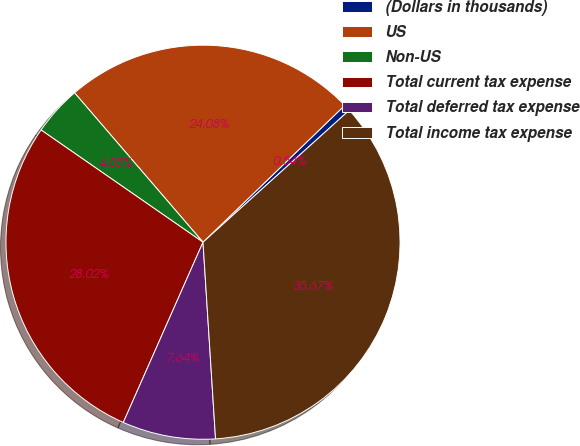<chart> <loc_0><loc_0><loc_500><loc_500><pie_chart><fcel>(Dollars in thousands)<fcel>US<fcel>Non-US<fcel>Total current tax expense<fcel>Total deferred tax expense<fcel>Total income tax expense<nl><fcel>0.54%<fcel>24.08%<fcel>4.05%<fcel>28.02%<fcel>7.64%<fcel>35.67%<nl></chart> 